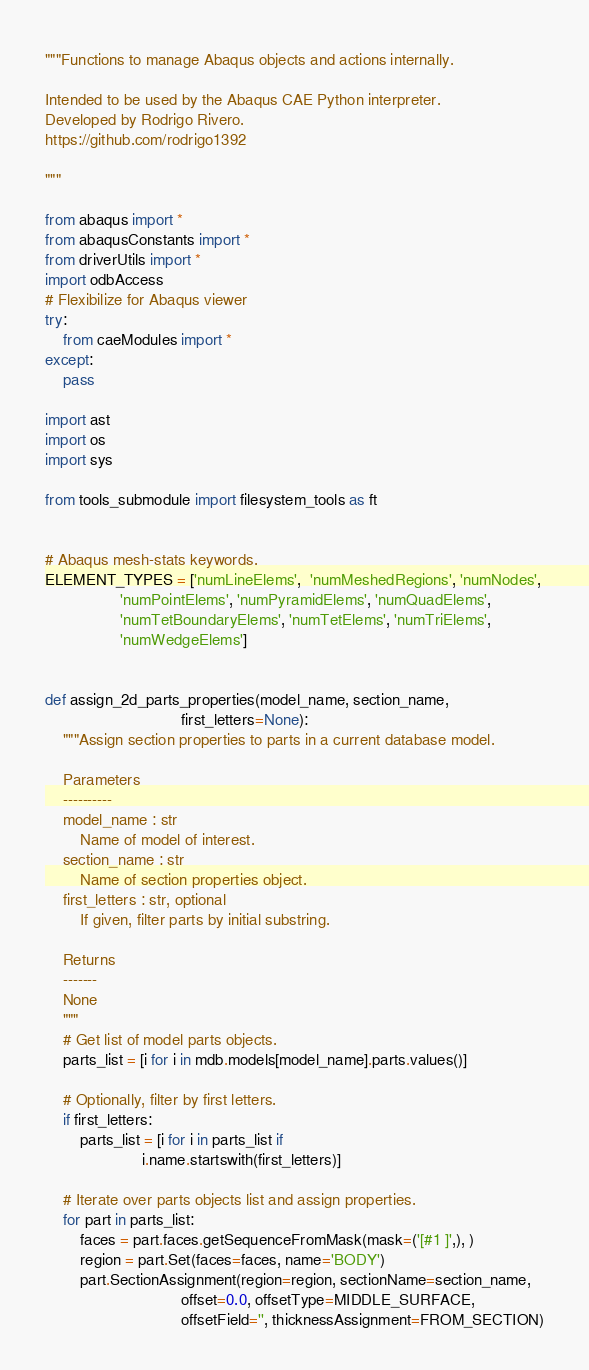Convert code to text. <code><loc_0><loc_0><loc_500><loc_500><_Python_>"""Functions to manage Abaqus objects and actions internally.

Intended to be used by the Abaqus CAE Python interpreter.
Developed by Rodrigo Rivero.
https://github.com/rodrigo1392

"""

from abaqus import *
from abaqusConstants import *
from driverUtils import *
import odbAccess
# Flexibilize for Abaqus viewer
try:
    from caeModules import *
except:
    pass

import ast
import os
import sys

from tools_submodule import filesystem_tools as ft


# Abaqus mesh-stats keywords.
ELEMENT_TYPES = ['numLineElems',  'numMeshedRegions', 'numNodes',
                 'numPointElems', 'numPyramidElems', 'numQuadElems',
                 'numTetBoundaryElems', 'numTetElems', 'numTriElems',
                 'numWedgeElems']


def assign_2d_parts_properties(model_name, section_name,
                               first_letters=None):
    """Assign section properties to parts in a current database model.

    Parameters
    ----------
    model_name : str
        Name of model of interest.
    section_name : str
        Name of section properties object.
    first_letters : str, optional
        If given, filter parts by initial substring.

    Returns
    -------
    None
    """
    # Get list of model parts objects.
    parts_list = [i for i in mdb.models[model_name].parts.values()]

    # Optionally, filter by first letters.
    if first_letters:
        parts_list = [i for i in parts_list if
                      i.name.startswith(first_letters)]

    # Iterate over parts objects list and assign properties.
    for part in parts_list:
        faces = part.faces.getSequenceFromMask(mask=('[#1 ]',), )
        region = part.Set(faces=faces, name='BODY')
        part.SectionAssignment(region=region, sectionName=section_name,
                               offset=0.0, offsetType=MIDDLE_SURFACE,
                               offsetField='', thicknessAssignment=FROM_SECTION)

</code> 